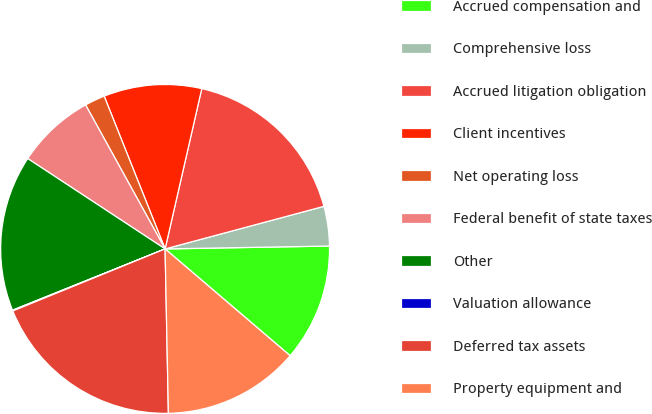Convert chart. <chart><loc_0><loc_0><loc_500><loc_500><pie_chart><fcel>Accrued compensation and<fcel>Comprehensive loss<fcel>Accrued litigation obligation<fcel>Client incentives<fcel>Net operating loss<fcel>Federal benefit of state taxes<fcel>Other<fcel>Valuation allowance<fcel>Deferred tax assets<fcel>Property equipment and<nl><fcel>11.53%<fcel>3.89%<fcel>17.25%<fcel>9.62%<fcel>1.99%<fcel>7.71%<fcel>15.34%<fcel>0.08%<fcel>19.16%<fcel>13.43%<nl></chart> 